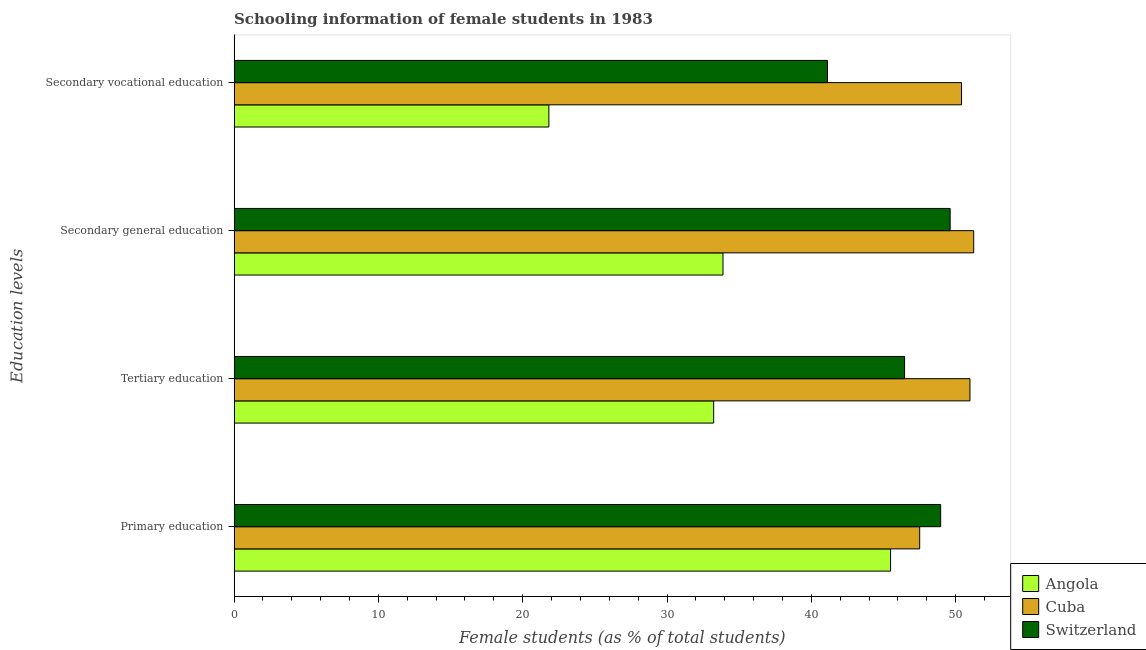How many different coloured bars are there?
Offer a terse response. 3. Are the number of bars on each tick of the Y-axis equal?
Provide a succinct answer. Yes. How many bars are there on the 2nd tick from the top?
Offer a terse response. 3. How many bars are there on the 4th tick from the bottom?
Offer a very short reply. 3. What is the percentage of female students in secondary vocational education in Angola?
Make the answer very short. 21.81. Across all countries, what is the maximum percentage of female students in secondary education?
Your answer should be very brief. 51.26. Across all countries, what is the minimum percentage of female students in secondary vocational education?
Offer a very short reply. 21.81. In which country was the percentage of female students in secondary education maximum?
Your answer should be compact. Cuba. In which country was the percentage of female students in tertiary education minimum?
Your answer should be compact. Angola. What is the total percentage of female students in tertiary education in the graph?
Offer a very short reply. 130.69. What is the difference between the percentage of female students in tertiary education in Cuba and that in Angola?
Offer a terse response. 17.76. What is the difference between the percentage of female students in primary education in Cuba and the percentage of female students in secondary education in Angola?
Your response must be concise. 13.63. What is the average percentage of female students in secondary education per country?
Keep it short and to the point. 44.92. What is the difference between the percentage of female students in secondary education and percentage of female students in tertiary education in Angola?
Provide a succinct answer. 0.65. In how many countries, is the percentage of female students in secondary education greater than 20 %?
Offer a terse response. 3. What is the ratio of the percentage of female students in tertiary education in Switzerland to that in Cuba?
Your answer should be compact. 0.91. Is the percentage of female students in tertiary education in Cuba less than that in Switzerland?
Your response must be concise. No. What is the difference between the highest and the second highest percentage of female students in secondary vocational education?
Offer a terse response. 9.29. What is the difference between the highest and the lowest percentage of female students in primary education?
Keep it short and to the point. 3.47. In how many countries, is the percentage of female students in tertiary education greater than the average percentage of female students in tertiary education taken over all countries?
Your answer should be very brief. 2. Is the sum of the percentage of female students in secondary vocational education in Cuba and Switzerland greater than the maximum percentage of female students in primary education across all countries?
Give a very brief answer. Yes. What does the 2nd bar from the top in Tertiary education represents?
Provide a short and direct response. Cuba. What does the 2nd bar from the bottom in Secondary vocational education represents?
Give a very brief answer. Cuba. Is it the case that in every country, the sum of the percentage of female students in primary education and percentage of female students in tertiary education is greater than the percentage of female students in secondary education?
Ensure brevity in your answer.  Yes. What is the difference between two consecutive major ticks on the X-axis?
Provide a short and direct response. 10. Does the graph contain any zero values?
Ensure brevity in your answer.  No. Does the graph contain grids?
Keep it short and to the point. No. Where does the legend appear in the graph?
Give a very brief answer. Bottom right. How many legend labels are there?
Your response must be concise. 3. What is the title of the graph?
Give a very brief answer. Schooling information of female students in 1983. Does "Oman" appear as one of the legend labels in the graph?
Offer a very short reply. No. What is the label or title of the X-axis?
Provide a succinct answer. Female students (as % of total students). What is the label or title of the Y-axis?
Offer a very short reply. Education levels. What is the Female students (as % of total students) of Angola in Primary education?
Make the answer very short. 45.49. What is the Female students (as % of total students) of Cuba in Primary education?
Provide a succinct answer. 47.51. What is the Female students (as % of total students) in Switzerland in Primary education?
Keep it short and to the point. 48.96. What is the Female students (as % of total students) of Angola in Tertiary education?
Ensure brevity in your answer.  33.23. What is the Female students (as % of total students) in Cuba in Tertiary education?
Give a very brief answer. 51. What is the Female students (as % of total students) of Switzerland in Tertiary education?
Offer a very short reply. 46.46. What is the Female students (as % of total students) of Angola in Secondary general education?
Offer a very short reply. 33.88. What is the Female students (as % of total students) in Cuba in Secondary general education?
Make the answer very short. 51.26. What is the Female students (as % of total students) of Switzerland in Secondary general education?
Ensure brevity in your answer.  49.62. What is the Female students (as % of total students) in Angola in Secondary vocational education?
Offer a very short reply. 21.81. What is the Female students (as % of total students) in Cuba in Secondary vocational education?
Your answer should be compact. 50.41. What is the Female students (as % of total students) of Switzerland in Secondary vocational education?
Keep it short and to the point. 41.12. Across all Education levels, what is the maximum Female students (as % of total students) of Angola?
Provide a succinct answer. 45.49. Across all Education levels, what is the maximum Female students (as % of total students) in Cuba?
Provide a succinct answer. 51.26. Across all Education levels, what is the maximum Female students (as % of total students) of Switzerland?
Give a very brief answer. 49.62. Across all Education levels, what is the minimum Female students (as % of total students) in Angola?
Keep it short and to the point. 21.81. Across all Education levels, what is the minimum Female students (as % of total students) of Cuba?
Your answer should be compact. 47.51. Across all Education levels, what is the minimum Female students (as % of total students) of Switzerland?
Provide a succinct answer. 41.12. What is the total Female students (as % of total students) of Angola in the graph?
Give a very brief answer. 134.42. What is the total Female students (as % of total students) in Cuba in the graph?
Offer a terse response. 200.18. What is the total Female students (as % of total students) of Switzerland in the graph?
Your answer should be very brief. 186.17. What is the difference between the Female students (as % of total students) of Angola in Primary education and that in Tertiary education?
Your answer should be compact. 12.26. What is the difference between the Female students (as % of total students) of Cuba in Primary education and that in Tertiary education?
Ensure brevity in your answer.  -3.49. What is the difference between the Female students (as % of total students) in Switzerland in Primary education and that in Tertiary education?
Give a very brief answer. 2.5. What is the difference between the Female students (as % of total students) of Angola in Primary education and that in Secondary general education?
Offer a terse response. 11.61. What is the difference between the Female students (as % of total students) of Cuba in Primary education and that in Secondary general education?
Your answer should be compact. -3.74. What is the difference between the Female students (as % of total students) of Switzerland in Primary education and that in Secondary general education?
Give a very brief answer. -0.66. What is the difference between the Female students (as % of total students) in Angola in Primary education and that in Secondary vocational education?
Provide a short and direct response. 23.68. What is the difference between the Female students (as % of total students) in Cuba in Primary education and that in Secondary vocational education?
Your response must be concise. -2.9. What is the difference between the Female students (as % of total students) in Switzerland in Primary education and that in Secondary vocational education?
Offer a very short reply. 7.84. What is the difference between the Female students (as % of total students) of Angola in Tertiary education and that in Secondary general education?
Offer a very short reply. -0.65. What is the difference between the Female students (as % of total students) in Cuba in Tertiary education and that in Secondary general education?
Offer a terse response. -0.26. What is the difference between the Female students (as % of total students) of Switzerland in Tertiary education and that in Secondary general education?
Make the answer very short. -3.16. What is the difference between the Female students (as % of total students) in Angola in Tertiary education and that in Secondary vocational education?
Give a very brief answer. 11.42. What is the difference between the Female students (as % of total students) in Cuba in Tertiary education and that in Secondary vocational education?
Keep it short and to the point. 0.58. What is the difference between the Female students (as % of total students) in Switzerland in Tertiary education and that in Secondary vocational education?
Ensure brevity in your answer.  5.34. What is the difference between the Female students (as % of total students) in Angola in Secondary general education and that in Secondary vocational education?
Your response must be concise. 12.07. What is the difference between the Female students (as % of total students) in Cuba in Secondary general education and that in Secondary vocational education?
Your answer should be compact. 0.84. What is the difference between the Female students (as % of total students) in Switzerland in Secondary general education and that in Secondary vocational education?
Provide a short and direct response. 8.5. What is the difference between the Female students (as % of total students) in Angola in Primary education and the Female students (as % of total students) in Cuba in Tertiary education?
Offer a terse response. -5.5. What is the difference between the Female students (as % of total students) in Angola in Primary education and the Female students (as % of total students) in Switzerland in Tertiary education?
Provide a succinct answer. -0.97. What is the difference between the Female students (as % of total students) of Cuba in Primary education and the Female students (as % of total students) of Switzerland in Tertiary education?
Ensure brevity in your answer.  1.05. What is the difference between the Female students (as % of total students) of Angola in Primary education and the Female students (as % of total students) of Cuba in Secondary general education?
Your answer should be very brief. -5.76. What is the difference between the Female students (as % of total students) in Angola in Primary education and the Female students (as % of total students) in Switzerland in Secondary general education?
Your answer should be very brief. -4.13. What is the difference between the Female students (as % of total students) in Cuba in Primary education and the Female students (as % of total students) in Switzerland in Secondary general education?
Provide a short and direct response. -2.11. What is the difference between the Female students (as % of total students) of Angola in Primary education and the Female students (as % of total students) of Cuba in Secondary vocational education?
Give a very brief answer. -4.92. What is the difference between the Female students (as % of total students) of Angola in Primary education and the Female students (as % of total students) of Switzerland in Secondary vocational education?
Provide a short and direct response. 4.37. What is the difference between the Female students (as % of total students) in Cuba in Primary education and the Female students (as % of total students) in Switzerland in Secondary vocational education?
Keep it short and to the point. 6.39. What is the difference between the Female students (as % of total students) of Angola in Tertiary education and the Female students (as % of total students) of Cuba in Secondary general education?
Your answer should be compact. -18.02. What is the difference between the Female students (as % of total students) of Angola in Tertiary education and the Female students (as % of total students) of Switzerland in Secondary general education?
Give a very brief answer. -16.39. What is the difference between the Female students (as % of total students) in Cuba in Tertiary education and the Female students (as % of total students) in Switzerland in Secondary general education?
Your answer should be compact. 1.37. What is the difference between the Female students (as % of total students) in Angola in Tertiary education and the Female students (as % of total students) in Cuba in Secondary vocational education?
Your response must be concise. -17.18. What is the difference between the Female students (as % of total students) in Angola in Tertiary education and the Female students (as % of total students) in Switzerland in Secondary vocational education?
Your answer should be compact. -7.89. What is the difference between the Female students (as % of total students) in Cuba in Tertiary education and the Female students (as % of total students) in Switzerland in Secondary vocational education?
Provide a short and direct response. 9.88. What is the difference between the Female students (as % of total students) of Angola in Secondary general education and the Female students (as % of total students) of Cuba in Secondary vocational education?
Offer a very short reply. -16.53. What is the difference between the Female students (as % of total students) in Angola in Secondary general education and the Female students (as % of total students) in Switzerland in Secondary vocational education?
Offer a very short reply. -7.24. What is the difference between the Female students (as % of total students) of Cuba in Secondary general education and the Female students (as % of total students) of Switzerland in Secondary vocational education?
Your answer should be compact. 10.13. What is the average Female students (as % of total students) in Angola per Education levels?
Keep it short and to the point. 33.61. What is the average Female students (as % of total students) in Cuba per Education levels?
Provide a succinct answer. 50.04. What is the average Female students (as % of total students) of Switzerland per Education levels?
Make the answer very short. 46.54. What is the difference between the Female students (as % of total students) in Angola and Female students (as % of total students) in Cuba in Primary education?
Your answer should be compact. -2.02. What is the difference between the Female students (as % of total students) of Angola and Female students (as % of total students) of Switzerland in Primary education?
Offer a very short reply. -3.47. What is the difference between the Female students (as % of total students) of Cuba and Female students (as % of total students) of Switzerland in Primary education?
Provide a succinct answer. -1.45. What is the difference between the Female students (as % of total students) of Angola and Female students (as % of total students) of Cuba in Tertiary education?
Offer a terse response. -17.76. What is the difference between the Female students (as % of total students) in Angola and Female students (as % of total students) in Switzerland in Tertiary education?
Provide a short and direct response. -13.23. What is the difference between the Female students (as % of total students) of Cuba and Female students (as % of total students) of Switzerland in Tertiary education?
Ensure brevity in your answer.  4.53. What is the difference between the Female students (as % of total students) of Angola and Female students (as % of total students) of Cuba in Secondary general education?
Give a very brief answer. -17.38. What is the difference between the Female students (as % of total students) in Angola and Female students (as % of total students) in Switzerland in Secondary general education?
Provide a short and direct response. -15.74. What is the difference between the Female students (as % of total students) of Cuba and Female students (as % of total students) of Switzerland in Secondary general education?
Make the answer very short. 1.63. What is the difference between the Female students (as % of total students) of Angola and Female students (as % of total students) of Cuba in Secondary vocational education?
Your answer should be very brief. -28.6. What is the difference between the Female students (as % of total students) in Angola and Female students (as % of total students) in Switzerland in Secondary vocational education?
Your response must be concise. -19.31. What is the difference between the Female students (as % of total students) of Cuba and Female students (as % of total students) of Switzerland in Secondary vocational education?
Provide a succinct answer. 9.29. What is the ratio of the Female students (as % of total students) of Angola in Primary education to that in Tertiary education?
Your response must be concise. 1.37. What is the ratio of the Female students (as % of total students) in Cuba in Primary education to that in Tertiary education?
Give a very brief answer. 0.93. What is the ratio of the Female students (as % of total students) of Switzerland in Primary education to that in Tertiary education?
Give a very brief answer. 1.05. What is the ratio of the Female students (as % of total students) in Angola in Primary education to that in Secondary general education?
Ensure brevity in your answer.  1.34. What is the ratio of the Female students (as % of total students) in Cuba in Primary education to that in Secondary general education?
Ensure brevity in your answer.  0.93. What is the ratio of the Female students (as % of total students) of Switzerland in Primary education to that in Secondary general education?
Ensure brevity in your answer.  0.99. What is the ratio of the Female students (as % of total students) of Angola in Primary education to that in Secondary vocational education?
Ensure brevity in your answer.  2.09. What is the ratio of the Female students (as % of total students) in Cuba in Primary education to that in Secondary vocational education?
Your answer should be very brief. 0.94. What is the ratio of the Female students (as % of total students) of Switzerland in Primary education to that in Secondary vocational education?
Offer a terse response. 1.19. What is the ratio of the Female students (as % of total students) in Angola in Tertiary education to that in Secondary general education?
Keep it short and to the point. 0.98. What is the ratio of the Female students (as % of total students) in Cuba in Tertiary education to that in Secondary general education?
Your answer should be compact. 0.99. What is the ratio of the Female students (as % of total students) in Switzerland in Tertiary education to that in Secondary general education?
Ensure brevity in your answer.  0.94. What is the ratio of the Female students (as % of total students) in Angola in Tertiary education to that in Secondary vocational education?
Your answer should be very brief. 1.52. What is the ratio of the Female students (as % of total students) of Cuba in Tertiary education to that in Secondary vocational education?
Provide a short and direct response. 1.01. What is the ratio of the Female students (as % of total students) of Switzerland in Tertiary education to that in Secondary vocational education?
Your answer should be compact. 1.13. What is the ratio of the Female students (as % of total students) in Angola in Secondary general education to that in Secondary vocational education?
Your answer should be very brief. 1.55. What is the ratio of the Female students (as % of total students) of Cuba in Secondary general education to that in Secondary vocational education?
Keep it short and to the point. 1.02. What is the ratio of the Female students (as % of total students) of Switzerland in Secondary general education to that in Secondary vocational education?
Your answer should be compact. 1.21. What is the difference between the highest and the second highest Female students (as % of total students) in Angola?
Provide a succinct answer. 11.61. What is the difference between the highest and the second highest Female students (as % of total students) of Cuba?
Your response must be concise. 0.26. What is the difference between the highest and the second highest Female students (as % of total students) in Switzerland?
Offer a very short reply. 0.66. What is the difference between the highest and the lowest Female students (as % of total students) of Angola?
Offer a very short reply. 23.68. What is the difference between the highest and the lowest Female students (as % of total students) of Cuba?
Offer a terse response. 3.74. What is the difference between the highest and the lowest Female students (as % of total students) of Switzerland?
Give a very brief answer. 8.5. 